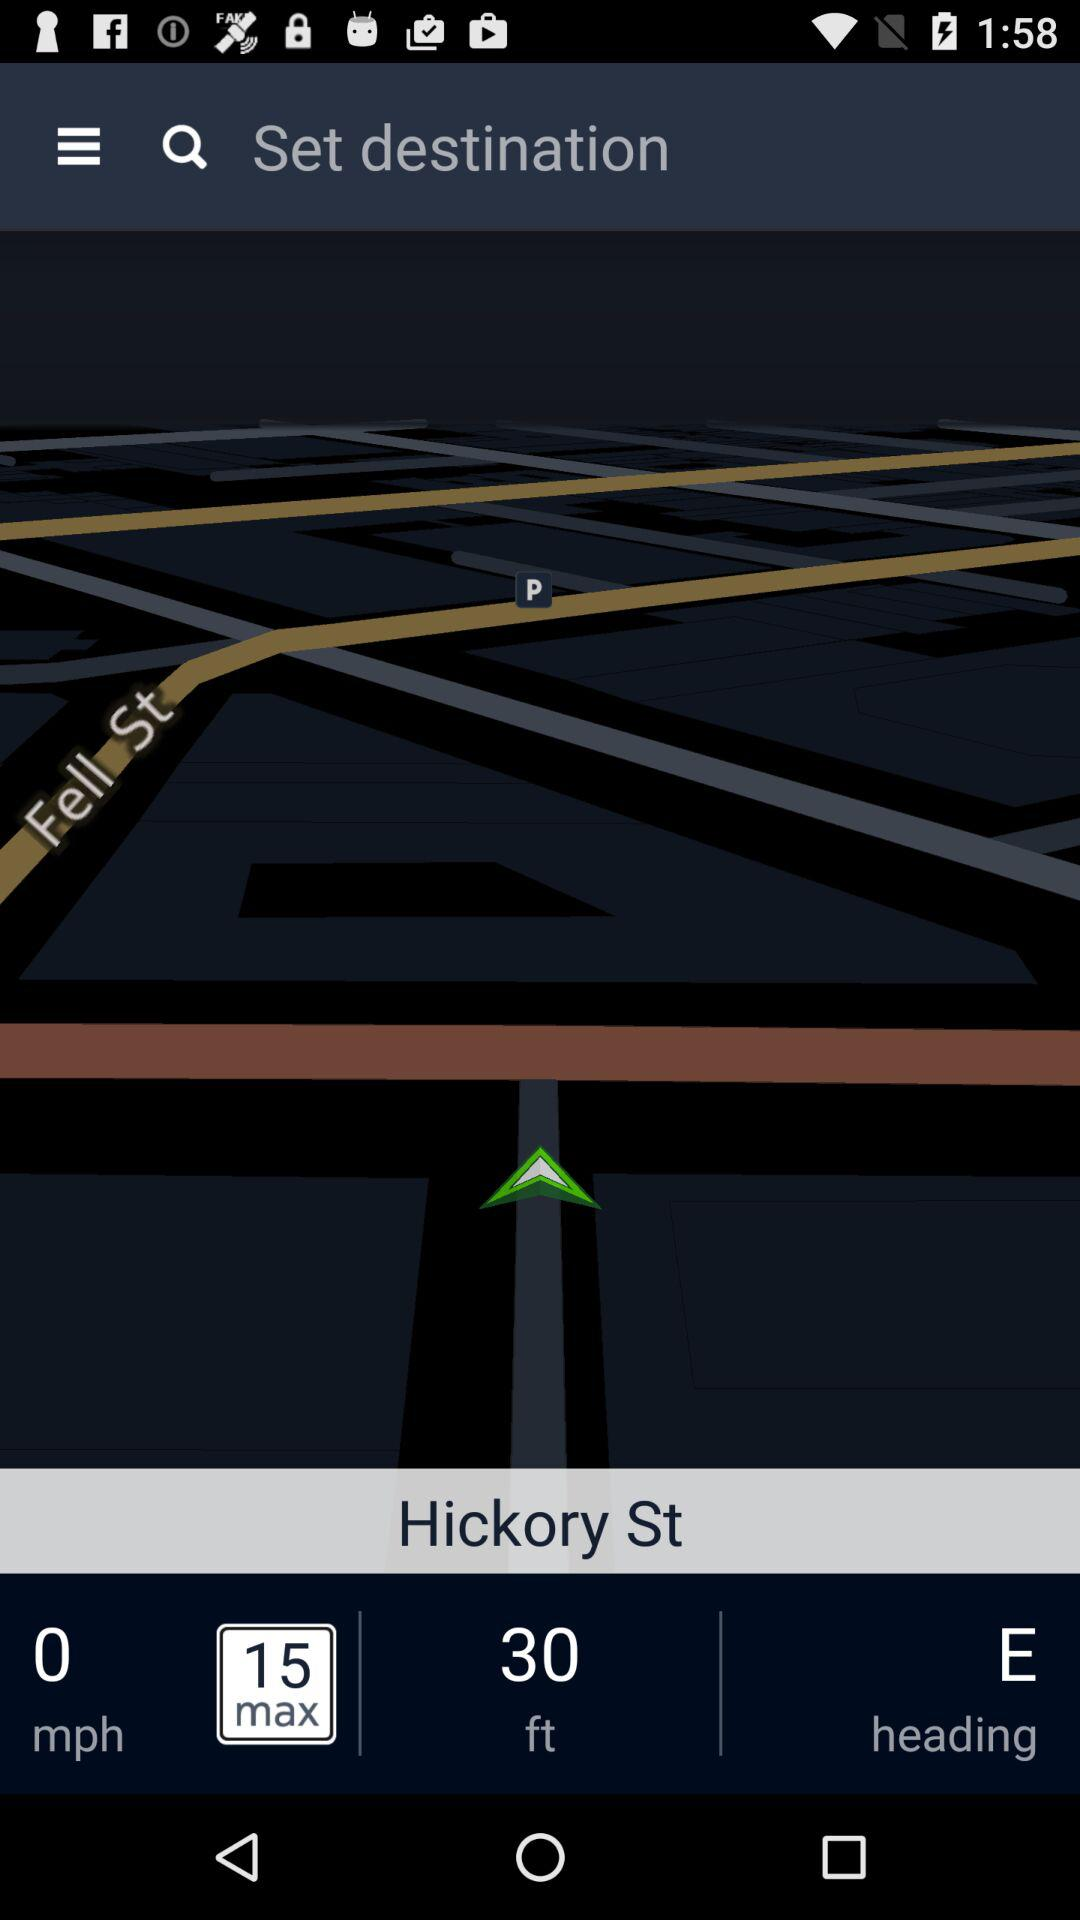What is the speed of "Hickory St"? The speed is 0 mph. 